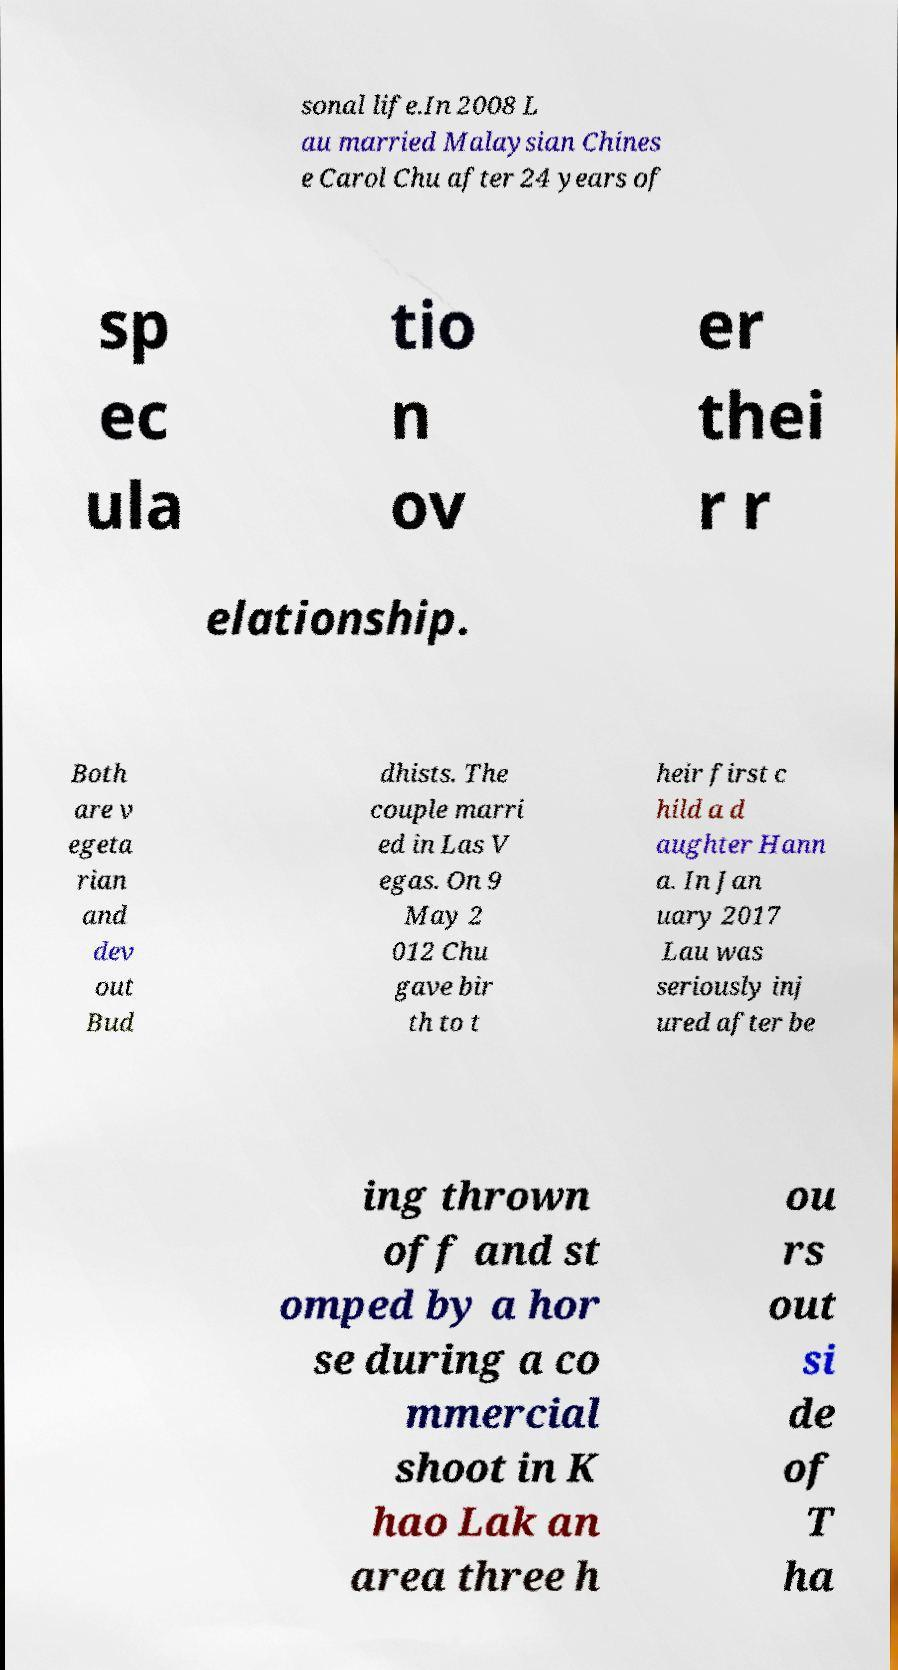I need the written content from this picture converted into text. Can you do that? sonal life.In 2008 L au married Malaysian Chines e Carol Chu after 24 years of sp ec ula tio n ov er thei r r elationship. Both are v egeta rian and dev out Bud dhists. The couple marri ed in Las V egas. On 9 May 2 012 Chu gave bir th to t heir first c hild a d aughter Hann a. In Jan uary 2017 Lau was seriously inj ured after be ing thrown off and st omped by a hor se during a co mmercial shoot in K hao Lak an area three h ou rs out si de of T ha 